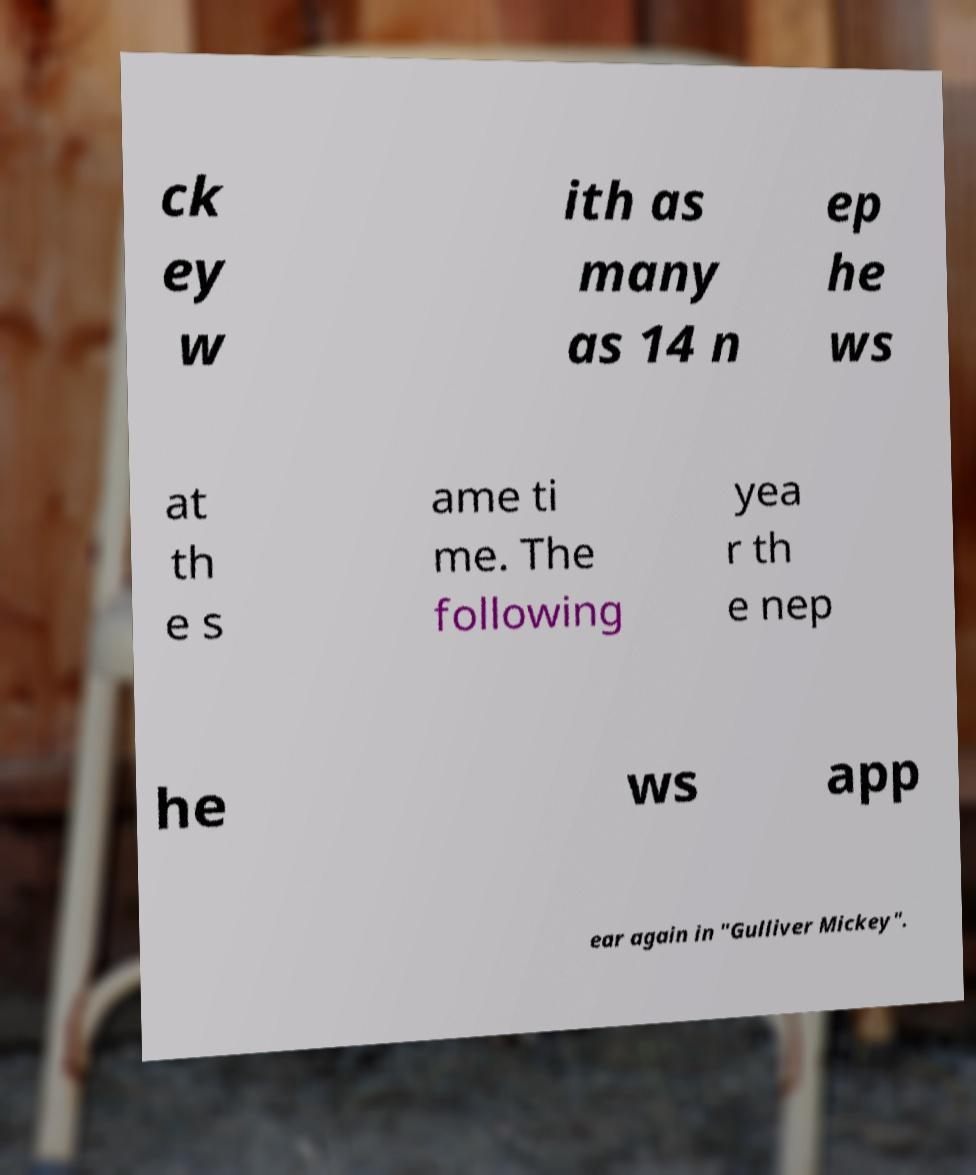Please identify and transcribe the text found in this image. ck ey w ith as many as 14 n ep he ws at th e s ame ti me. The following yea r th e nep he ws app ear again in "Gulliver Mickey". 